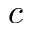<formula> <loc_0><loc_0><loc_500><loc_500>c</formula> 